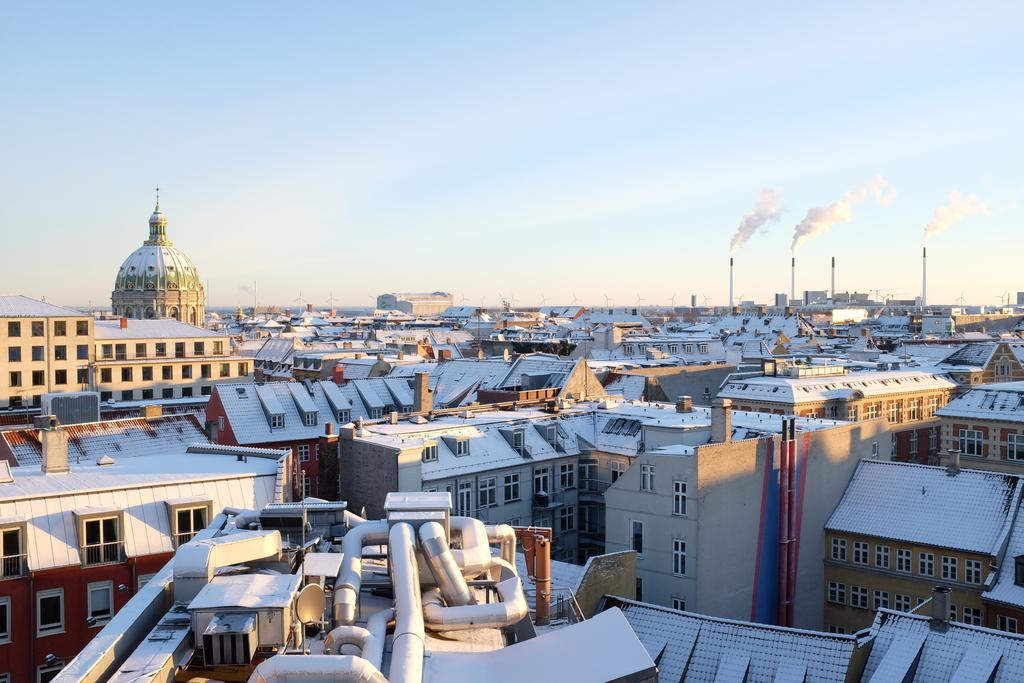What type of structures can be seen in the image? There are multiple buildings in the image. What architectural features are visible on the buildings? Multiple windows are visible in the image. What is present in the air in the image? There is smoke in the image. What can be seen in the distance in the image? The sky is visible in the background of the image. Where is the drawer located in the image? There is no drawer present in the image. What type of lunch is being served in the image? There is no lunch being served in the image. 